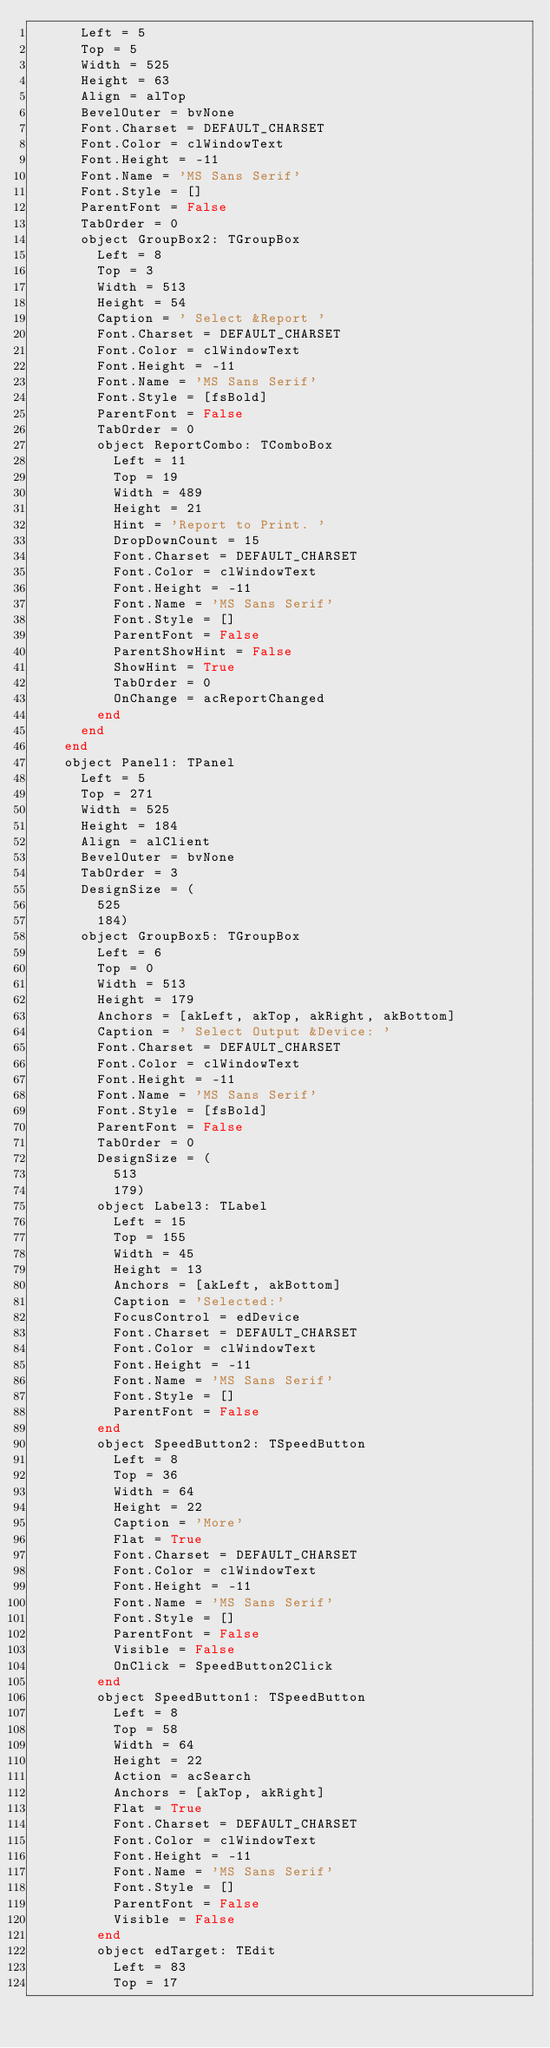<code> <loc_0><loc_0><loc_500><loc_500><_Pascal_>      Left = 5
      Top = 5
      Width = 525
      Height = 63
      Align = alTop
      BevelOuter = bvNone
      Font.Charset = DEFAULT_CHARSET
      Font.Color = clWindowText
      Font.Height = -11
      Font.Name = 'MS Sans Serif'
      Font.Style = []
      ParentFont = False
      TabOrder = 0
      object GroupBox2: TGroupBox
        Left = 8
        Top = 3
        Width = 513
        Height = 54
        Caption = ' Select &Report '
        Font.Charset = DEFAULT_CHARSET
        Font.Color = clWindowText
        Font.Height = -11
        Font.Name = 'MS Sans Serif'
        Font.Style = [fsBold]
        ParentFont = False
        TabOrder = 0
        object ReportCombo: TComboBox
          Left = 11
          Top = 19
          Width = 489
          Height = 21
          Hint = 'Report to Print. '
          DropDownCount = 15
          Font.Charset = DEFAULT_CHARSET
          Font.Color = clWindowText
          Font.Height = -11
          Font.Name = 'MS Sans Serif'
          Font.Style = []
          ParentFont = False
          ParentShowHint = False
          ShowHint = True
          TabOrder = 0
          OnChange = acReportChanged
        end
      end
    end
    object Panel1: TPanel
      Left = 5
      Top = 271
      Width = 525
      Height = 184
      Align = alClient
      BevelOuter = bvNone
      TabOrder = 3
      DesignSize = (
        525
        184)
      object GroupBox5: TGroupBox
        Left = 6
        Top = 0
        Width = 513
        Height = 179
        Anchors = [akLeft, akTop, akRight, akBottom]
        Caption = ' Select Output &Device: '
        Font.Charset = DEFAULT_CHARSET
        Font.Color = clWindowText
        Font.Height = -11
        Font.Name = 'MS Sans Serif'
        Font.Style = [fsBold]
        ParentFont = False
        TabOrder = 0
        DesignSize = (
          513
          179)
        object Label3: TLabel
          Left = 15
          Top = 155
          Width = 45
          Height = 13
          Anchors = [akLeft, akBottom]
          Caption = 'Selected:'
          FocusControl = edDevice
          Font.Charset = DEFAULT_CHARSET
          Font.Color = clWindowText
          Font.Height = -11
          Font.Name = 'MS Sans Serif'
          Font.Style = []
          ParentFont = False
        end
        object SpeedButton2: TSpeedButton
          Left = 8
          Top = 36
          Width = 64
          Height = 22
          Caption = 'More'
          Flat = True
          Font.Charset = DEFAULT_CHARSET
          Font.Color = clWindowText
          Font.Height = -11
          Font.Name = 'MS Sans Serif'
          Font.Style = []
          ParentFont = False
          Visible = False
          OnClick = SpeedButton2Click
        end
        object SpeedButton1: TSpeedButton
          Left = 8
          Top = 58
          Width = 64
          Height = 22
          Action = acSearch
          Anchors = [akTop, akRight]
          Flat = True
          Font.Charset = DEFAULT_CHARSET
          Font.Color = clWindowText
          Font.Height = -11
          Font.Name = 'MS Sans Serif'
          Font.Style = []
          ParentFont = False
          Visible = False
        end
        object edTarget: TEdit
          Left = 83
          Top = 17</code> 